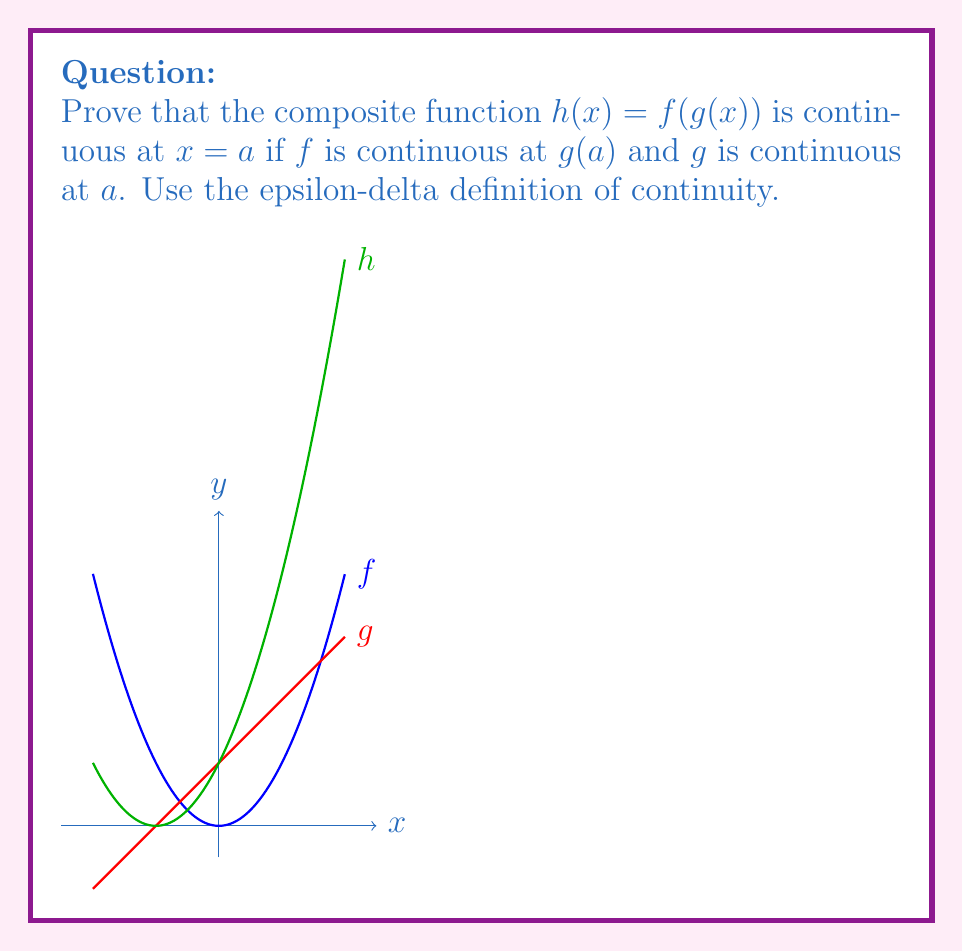Give your solution to this math problem. To prove the continuity of the composite function $h(x) = f(g(x))$ at $x = a$, we need to show that for any $\epsilon > 0$, there exists a $\delta > 0$ such that:

$$|h(x) - h(a)| < \epsilon \text{ whenever } |x - a| < \delta$$

Let's proceed step-by-step:

1) Given: $f$ is continuous at $g(a)$ and $g$ is continuous at $a$.

2) By the continuity of $f$ at $g(a)$, for any $\epsilon > 0$, there exists a $\delta_1 > 0$ such that:
   $$|f(y) - f(g(a))| < \epsilon \text{ whenever } |y - g(a)| < \delta_1$$

3) By the continuity of $g$ at $a$, for the $\delta_1$ found in step 2, there exists a $\delta > 0$ such that:
   $$|g(x) - g(a)| < \delta_1 \text{ whenever } |x - a| < \delta$$

4) Now, let's consider $|h(x) - h(a)|$:
   $$|h(x) - h(a)| = |f(g(x)) - f(g(a))|$$

5) From step 3, we know that if $|x - a| < \delta$, then $|g(x) - g(a)| < \delta_1$.

6) From step 2, we know that if $|g(x) - g(a)| < \delta_1$, then $|f(g(x)) - f(g(a))| < \epsilon$.

7) Combining steps 5 and 6, we can conclude that:
   $$|h(x) - h(a)| = |f(g(x)) - f(g(a))| < \epsilon \text{ whenever } |x - a| < \delta$$

This proves that $h(x)$ is continuous at $x = a$.
Answer: $h(x)$ is continuous at $x = a$ because for any $\epsilon > 0$, there exists a $\delta > 0$ such that $|h(x) - h(a)| < \epsilon$ whenever $|x - a| < \delta$. 